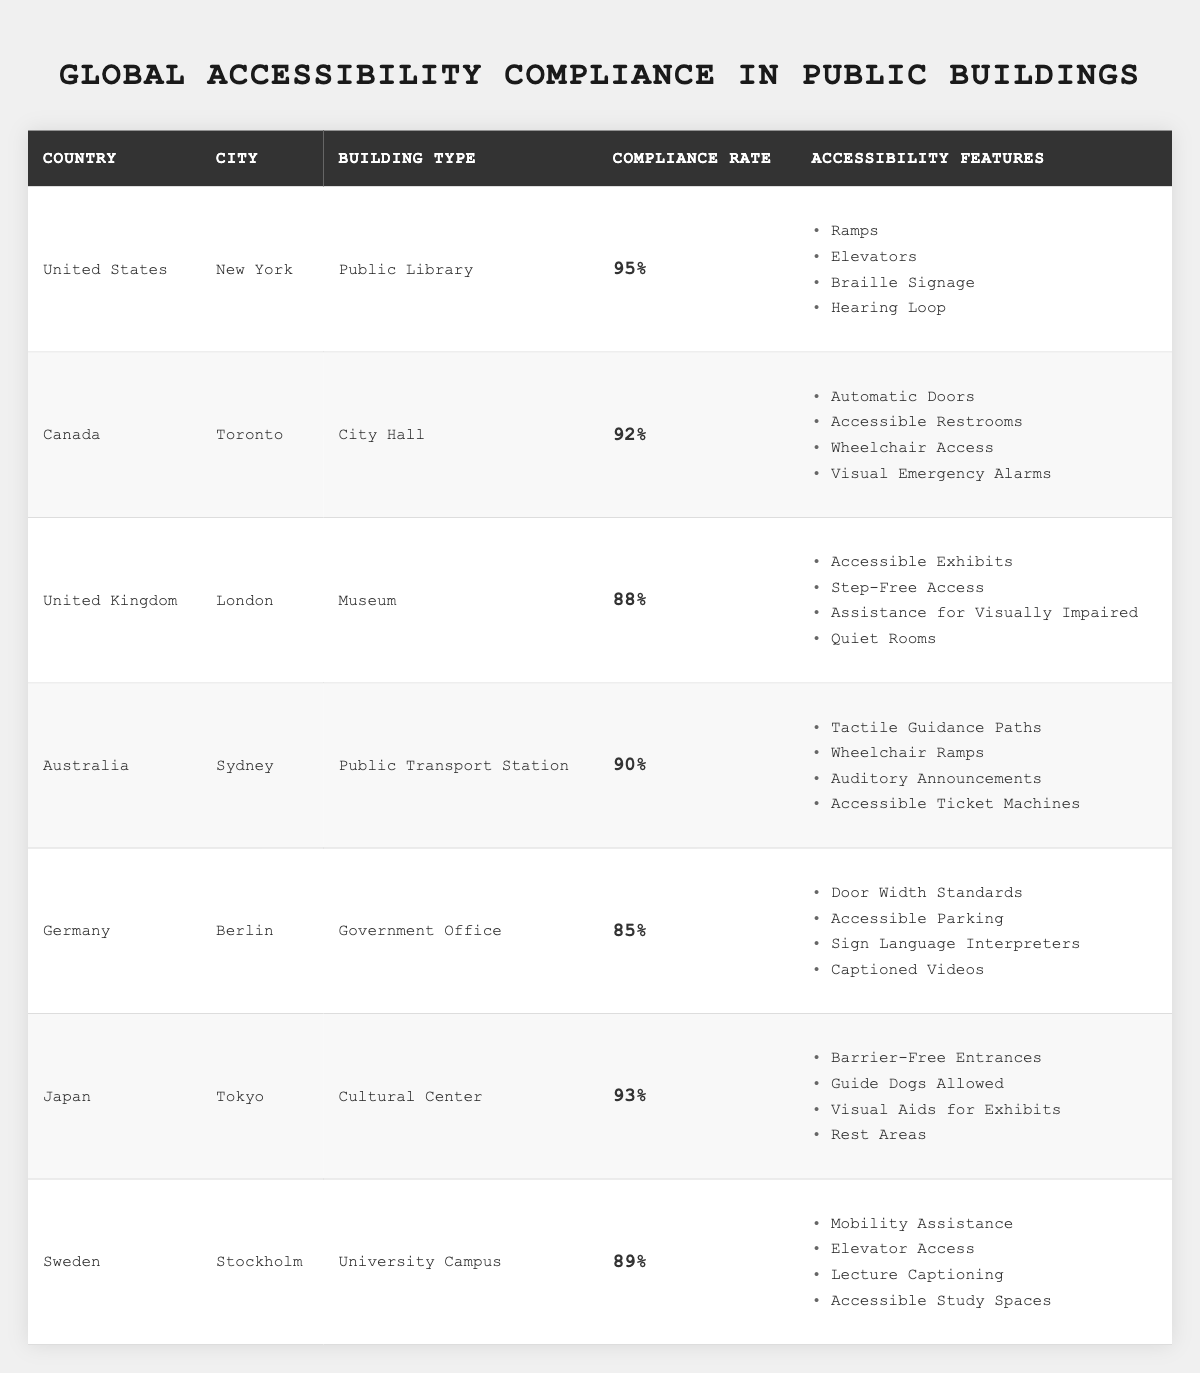What is the highest compliance rate among the public buildings listed? The table shows the compliance rates for each building, with the United States (New York, Public Library) at 95%, which is the highest.
Answer: 95% Which country has a compliance rate of 85%? By reviewing the data in the table, Germany (Berlin, Government Office) has a compliance rate listed as 85%.
Answer: Germany How many buildings have a compliance rate above 90%? The buildings with compliance rates above 90% are: United States (95%), Canada (92%), and Japan (93%). This totals three buildings.
Answer: 3 What accessibility features are available in the Museum in London? The table indicates that the London Museum offers: Accessible Exhibits, Step-Free Access, Assistance for Visually Impaired, and Quiet Rooms.
Answer: Accessible Exhibits, Step-Free Access, Assistance for Visually Impaired, Quiet Rooms Is there any building that allows guide dogs? The table shows that the Cultural Center in Japan specifically mentions 'Guide Dogs Allowed' as an accessibility feature, indicating this is true.
Answer: Yes What is the average compliance rate of the public buildings listed in the table? First, we sum the compliance rates: 95 + 92 + 88 + 90 + 85 + 93 + 89 = 620. Now, we divide the total by the number of buildings (7) to find the average: 620 / 7 = approximately 88.57.
Answer: 88.57 Which city has the lowest compliance rate and what is it? By examining the table, the lowest compliance rate is in Berlin, Germany, with a compliance rate of 85%.
Answer: Berlin, 85% How does the compliance rate of public transport station in Sydney compare to the museum in London? The compliance rate of the public transport station in Sydney is 90%, while the museum in London is 88%. Thus, Sydney’s public transport station has a higher compliance rate.
Answer: Sydney has a higher rate What accessibility features does the City Hall in Toronto offer compared to the Government Office in Berlin? The City Hall in Toronto offers Automatic Doors, Accessible Restrooms, Wheelchair Access, and Visual Emergency Alarms. In contrast, the Government Office in Berlin has Door Width Standards, Accessible Parking, Sign Language Interpreters, and Captioned Videos. Both provide different features.
Answer: Different features If we consider only buildings with a compliance rate below 90%, which countries are they from? The buildings with compliance rates below 90% are those from the United Kingdom (London), Australia (Sydney), Germany (Berlin), and Sweden (Stockholm). The corresponding compliance rates are 88%, 90%, 85%, and 89%, respectively, indicating the UK, Germany, and Sweden apply.
Answer: United Kingdom, Germany, Sweden 